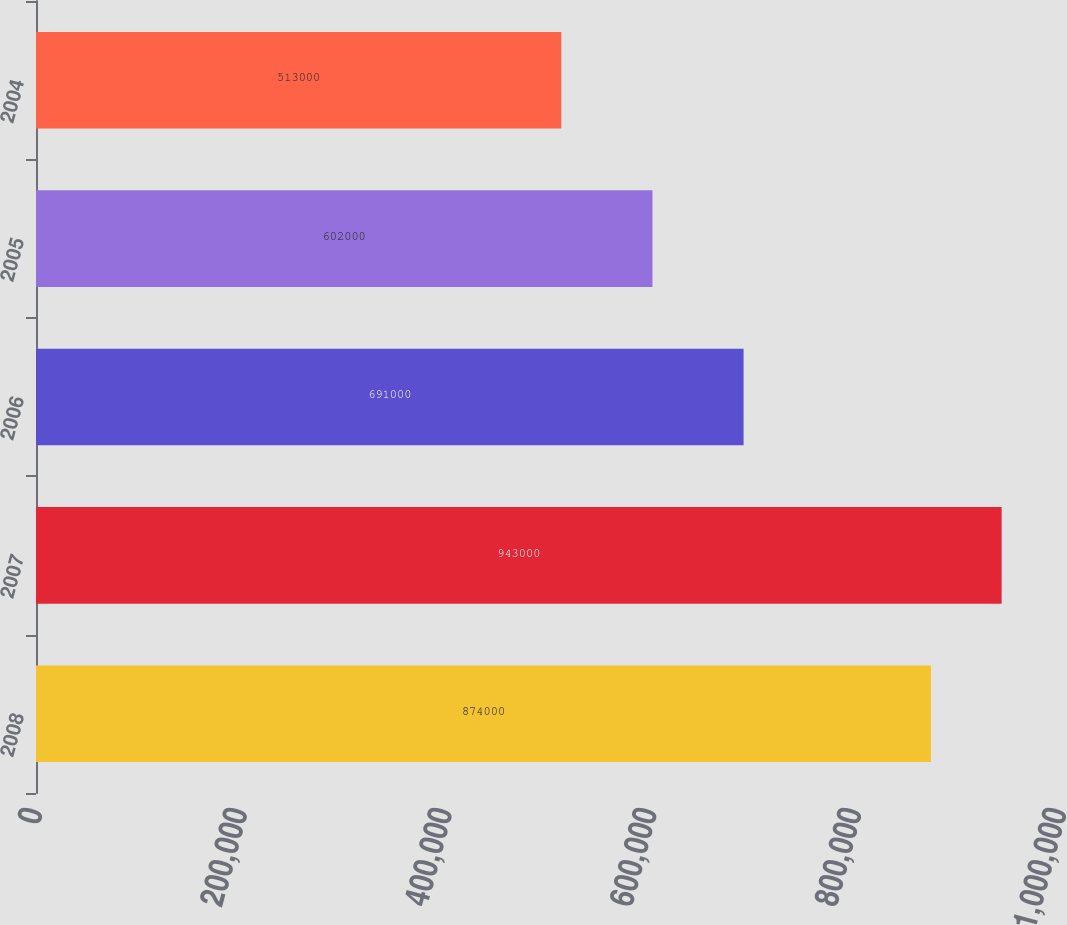<chart> <loc_0><loc_0><loc_500><loc_500><bar_chart><fcel>2008<fcel>2007<fcel>2006<fcel>2005<fcel>2004<nl><fcel>874000<fcel>943000<fcel>691000<fcel>602000<fcel>513000<nl></chart> 